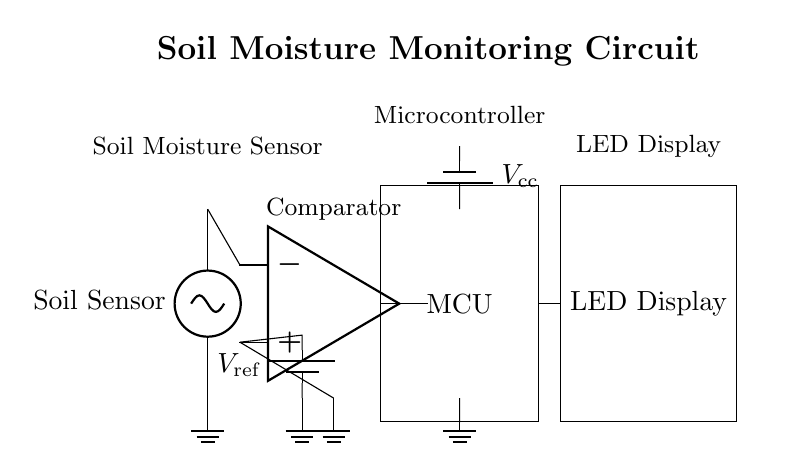What is the main function of the soil moisture sensor? The soil moisture sensor detects the moisture level in the soil, providing input to the comparator for further processing.
Answer: Soil moisture detection What component provides the reference voltage for the comparator? The circuit diagram shows a battery labeled as V_ref connected to the positive input of the comparator, indicating that it provides the reference voltage.
Answer: Battery What does the MCU stand for? The abbreviation MCU in the diagram refers to the Microcontroller Unit, which processes signals and controls the LED display based on soil moisture levels.
Answer: Microcontroller Unit How many main components are present in this circuit? By counting the unique components shown in the circuit, including the soil moisture sensor, comparator, microcontroller, and LED display, there are four main components.
Answer: Four What type of display is used to indicate soil moisture levels? The circuit includes an LED display as indicated by the label next to the rectangular component that represents it.
Answer: LED display What is the purpose of the comparator in this circuit? The comparator compares the input from the soil moisture sensor with the reference voltage to determine the output signal that the microcontroller will process.
Answer: Signal comparison What is the voltage supply labeled in the circuit? The voltage supply for the microcontroller is labeled as V_cc, indicating the voltage provided to power the microcontroller and associated components.
Answer: V_cc 